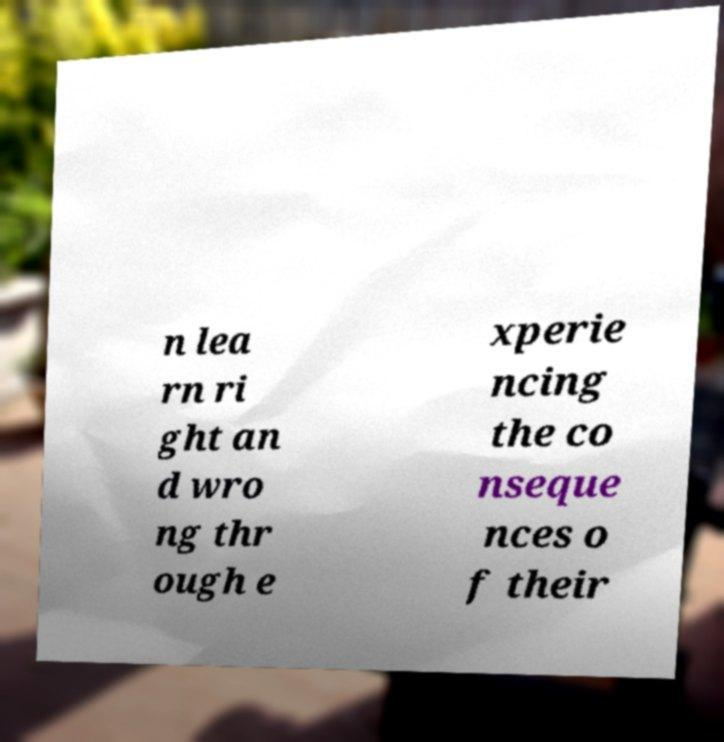Could you extract and type out the text from this image? n lea rn ri ght an d wro ng thr ough e xperie ncing the co nseque nces o f their 